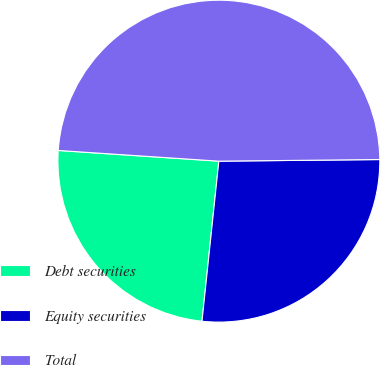<chart> <loc_0><loc_0><loc_500><loc_500><pie_chart><fcel>Debt securities<fcel>Equity securities<fcel>Total<nl><fcel>24.39%<fcel>26.83%<fcel>48.78%<nl></chart> 